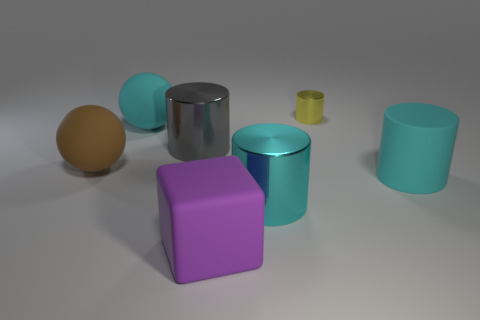Subtract all gray cylinders. How many cylinders are left? 3 Subtract all yellow cylinders. How many cylinders are left? 3 Subtract all blocks. How many objects are left? 6 Subtract 1 cylinders. How many cylinders are left? 3 Subtract all green spheres. Subtract all green cylinders. How many spheres are left? 2 Subtract all red cylinders. How many cyan blocks are left? 0 Subtract all brown matte things. Subtract all big matte cylinders. How many objects are left? 5 Add 2 cyan cylinders. How many cyan cylinders are left? 4 Add 1 small green things. How many small green things exist? 1 Add 2 big green things. How many objects exist? 9 